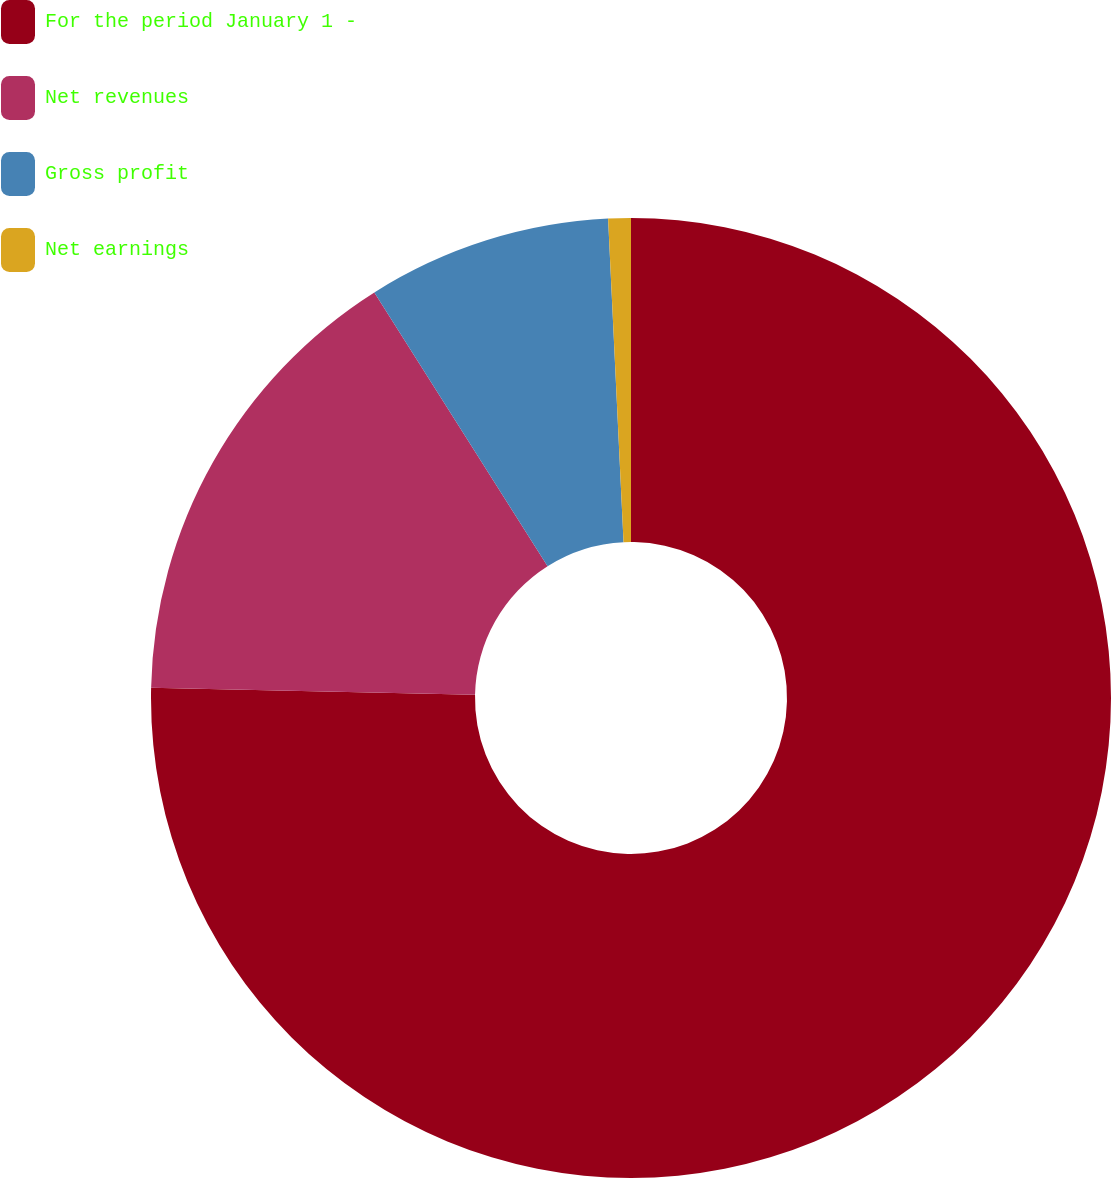Convert chart. <chart><loc_0><loc_0><loc_500><loc_500><pie_chart><fcel>For the period January 1 -<fcel>Net revenues<fcel>Gross profit<fcel>Net earnings<nl><fcel>75.35%<fcel>15.68%<fcel>8.22%<fcel>0.76%<nl></chart> 